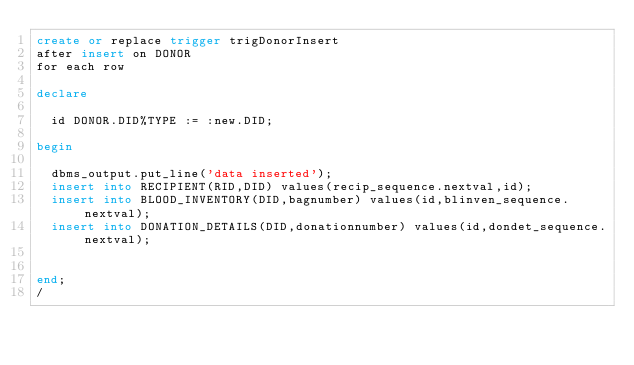Convert code to text. <code><loc_0><loc_0><loc_500><loc_500><_SQL_>create or replace trigger trigDonorInsert
after insert on DONOR
for each row

declare

	id DONOR.DID%TYPE := :new.DID;
	
begin

	dbms_output.put_line('data inserted');
	insert into RECIPIENT(RID,DID) values(recip_sequence.nextval,id);
	insert into BLOOD_INVENTORY(DID,bagnumber) values(id,blinven_sequence.nextval);
	insert into DONATION_DETAILS(DID,donationnumber) values(id,dondet_sequence.nextval);

	
end;
/</code> 